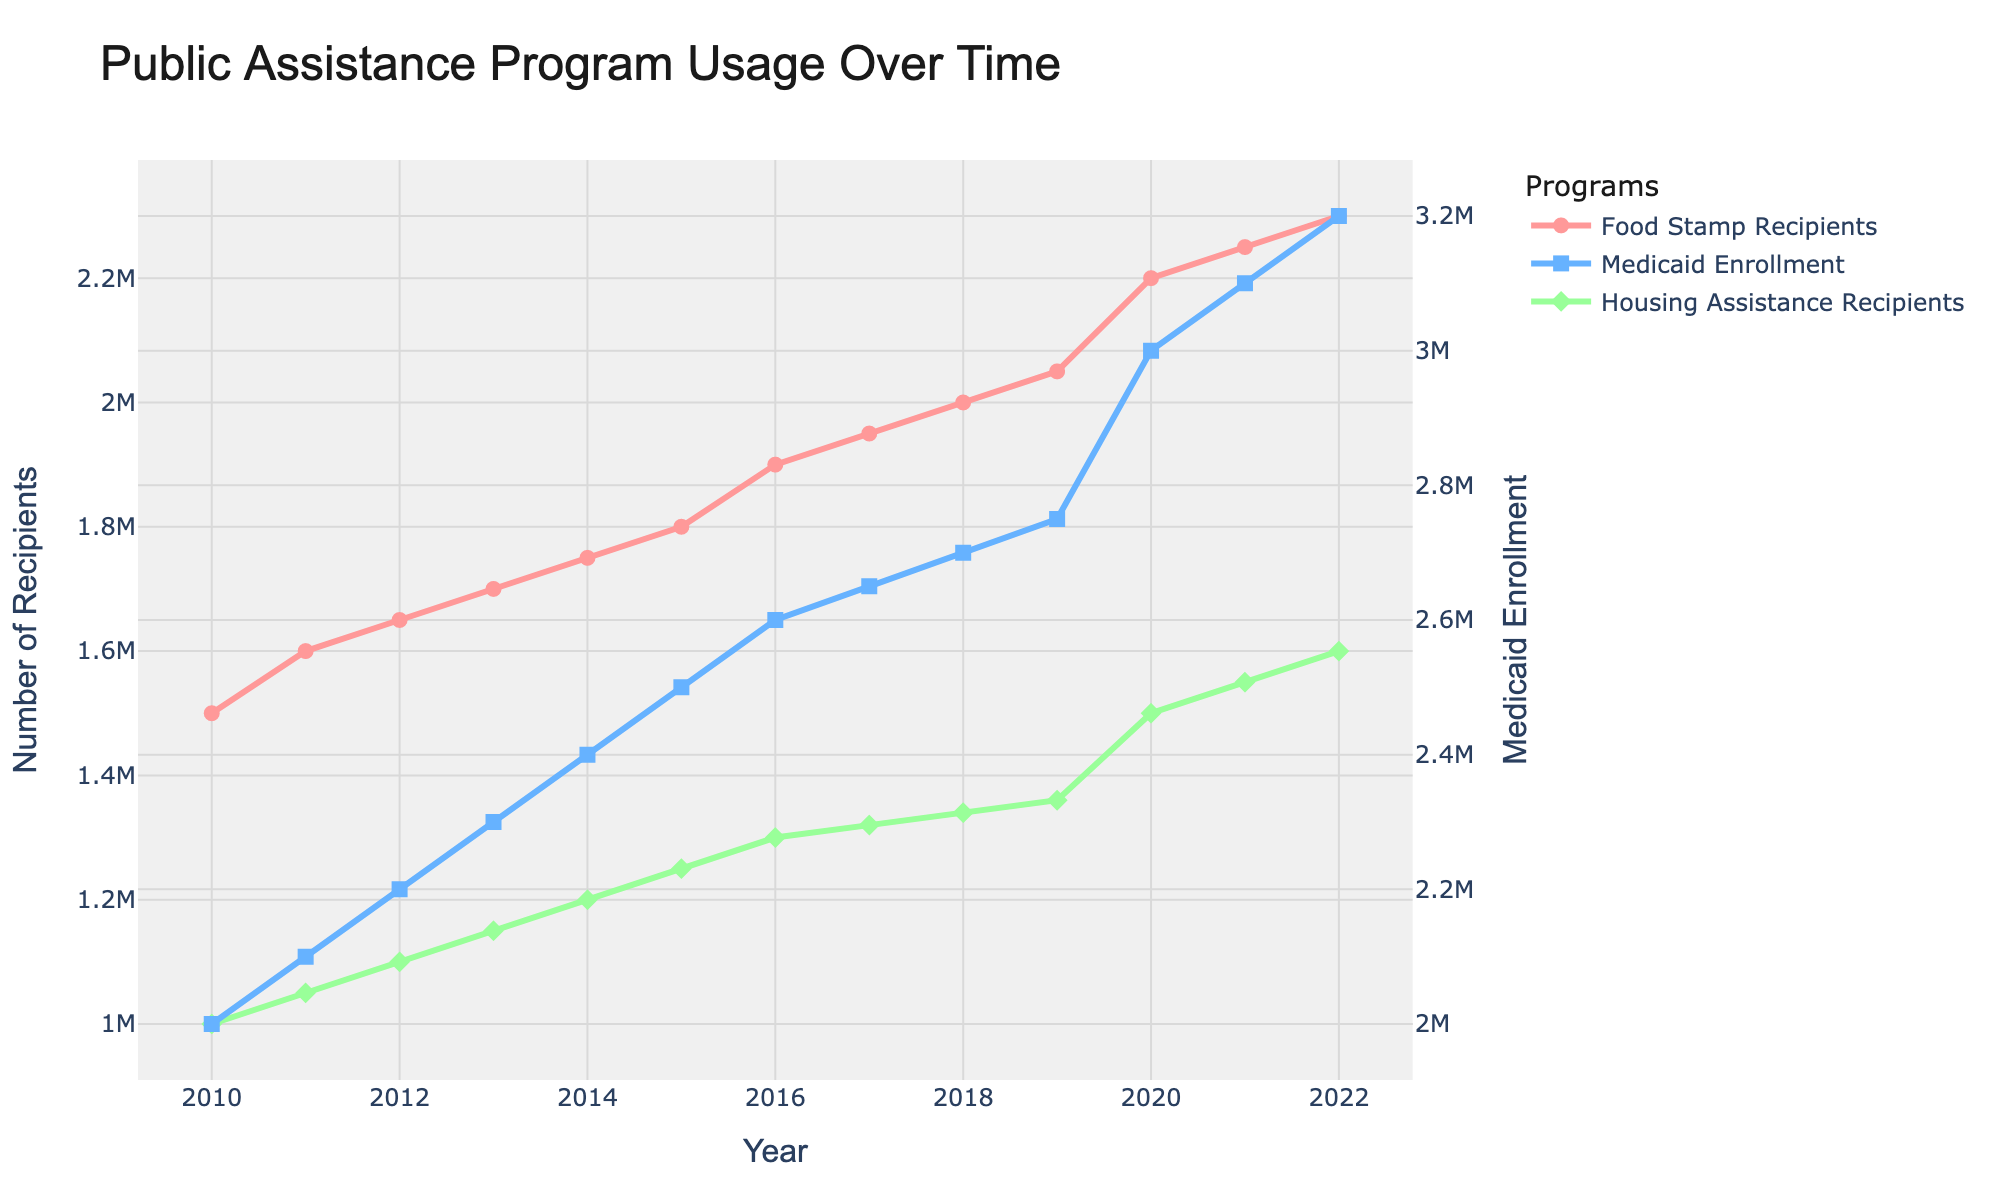What is the title of the figure? The title of the figure is displayed at the top of the plot. It reads "Public Assistance Program Usage Over Time".
Answer: Public Assistance Program Usage Over Time What is the range of years shown on the x-axis? The x-axis shows the time span from 2010 to 2022. This can be observed by looking at the first and last tick marks on the x-axis.
Answer: 2010 to 2022 What are the programs displayed in the figure? The figure displays three programs, as indicated by the legend. They are "Food Stamp Recipients", "Medicaid Enrollment", and "Housing Assistance Recipients".
Answer: Food Stamp Recipients, Medicaid Enrollment, Housing Assistance Recipients What year had the highest number of Medicaid Enrollment? To find the highest number, look for the peak of the blue line (Medicaid Enrollment) in the plot. The highest point is in the year 2022.
Answer: 2022 Between which years did Food Stamp Recipients see the largest single-year increase? The largest single-year increase for Food Stamp Recipients can be visually identified by observing the difference in the height of consecutive points along the pink line. The largest increase is between 2019 and 2020.
Answer: 2019 to 2020 How many recipients were there for Food Stamps in 2015? Look at the point on the pink line corresponding to the year 2015. The y-axis value for that point is 1,800,000.
Answer: 1,800,000 How does the number of Housing Assistance Recipients in 2022 compare to 2021? In the plot, compare the points for "Housing Assistance Recipients" (green diamond markers) for the years 2021 and 2022. The number in 2022 is higher than in 2021.
Answer: Higher What is the difference in the number of Housing Assistance Recipients between 2010 and 2022? Locate the points for Housing Assistance Recipients (green diamonds) for the years 2010 and 2022, then subtract the 2010 value (1,000,000) from the 2022 value (1,600,000). The difference is 600,000.
Answer: 600,000 Which program saw the most constant increase over time based on the trends observed? Examine the trends of the three lines in the plot. The green line for Housing Assistance Recipients shows the most consistent year-over-year increase compared to the other programs.
Answer: Housing Assistance Recipients What general trend can be observed in Medicaid Enrollment from 2010 to 2022? Observe the blue line representing Medicaid Enrollment from 2010 to 2022. The line shows an overall upward trend indicating that Medicaid Enrollment has increased over this period.
Answer: Upward trend 